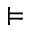<formula> <loc_0><loc_0><loc_500><loc_500>\vDash</formula> 